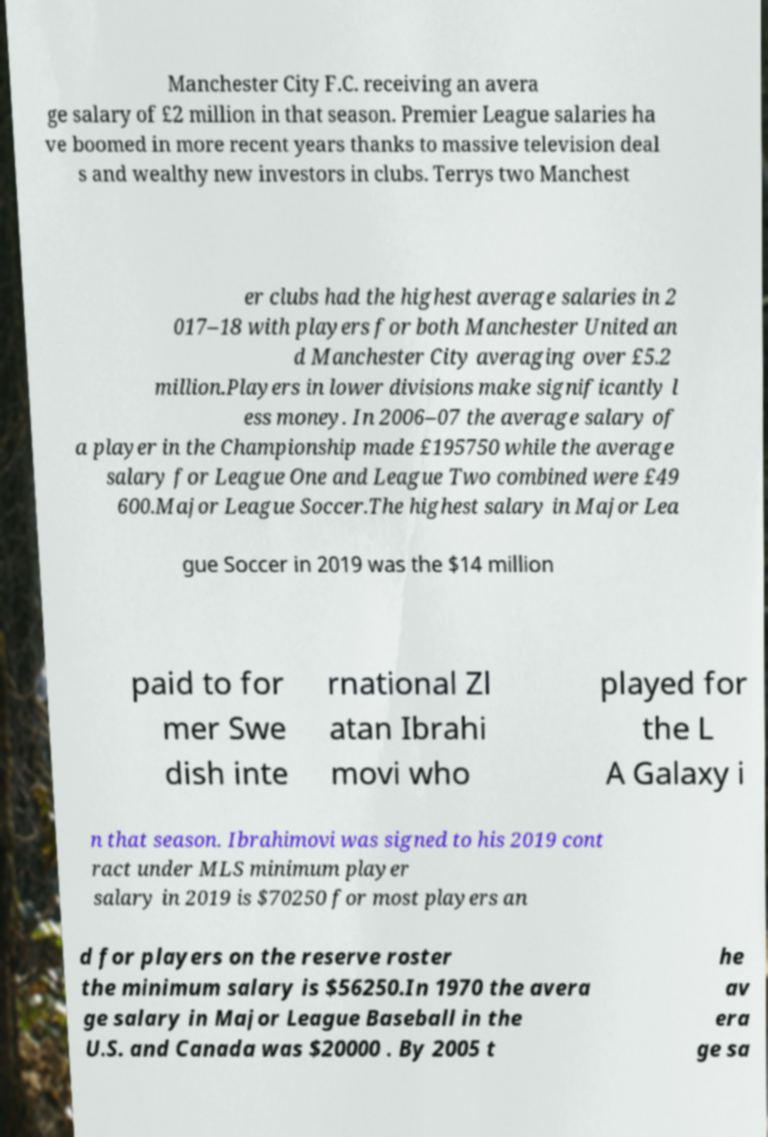Could you extract and type out the text from this image? Manchester City F.C. receiving an avera ge salary of £2 million in that season. Premier League salaries ha ve boomed in more recent years thanks to massive television deal s and wealthy new investors in clubs. Terrys two Manchest er clubs had the highest average salaries in 2 017–18 with players for both Manchester United an d Manchester City averaging over £5.2 million.Players in lower divisions make significantly l ess money. In 2006–07 the average salary of a player in the Championship made £195750 while the average salary for League One and League Two combined were £49 600.Major League Soccer.The highest salary in Major Lea gue Soccer in 2019 was the $14 million paid to for mer Swe dish inte rnational Zl atan Ibrahi movi who played for the L A Galaxy i n that season. Ibrahimovi was signed to his 2019 cont ract under MLS minimum player salary in 2019 is $70250 for most players an d for players on the reserve roster the minimum salary is $56250.In 1970 the avera ge salary in Major League Baseball in the U.S. and Canada was $20000 . By 2005 t he av era ge sa 